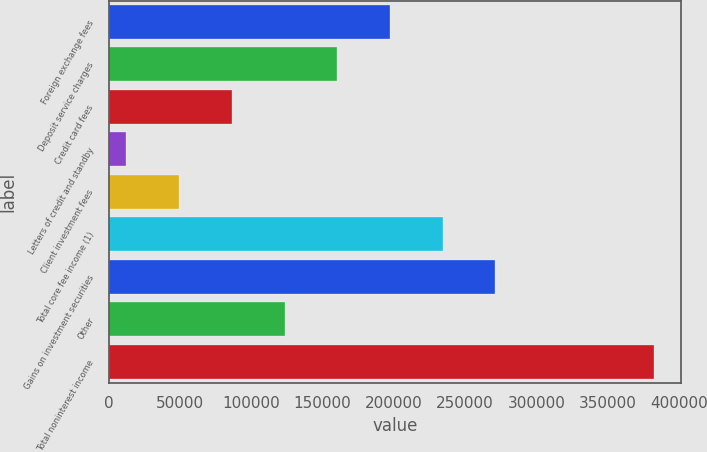Convert chart to OTSL. <chart><loc_0><loc_0><loc_500><loc_500><bar_chart><fcel>Foreign exchange fees<fcel>Deposit service charges<fcel>Credit card fees<fcel>Letters of credit and standby<fcel>Client investment fees<fcel>Total core fee income (1)<fcel>Gains on investment securities<fcel>Other<fcel>Total noninterest income<nl><fcel>197266<fcel>160253<fcel>86227.2<fcel>12201<fcel>49214.1<fcel>234280<fcel>271293<fcel>123240<fcel>382332<nl></chart> 